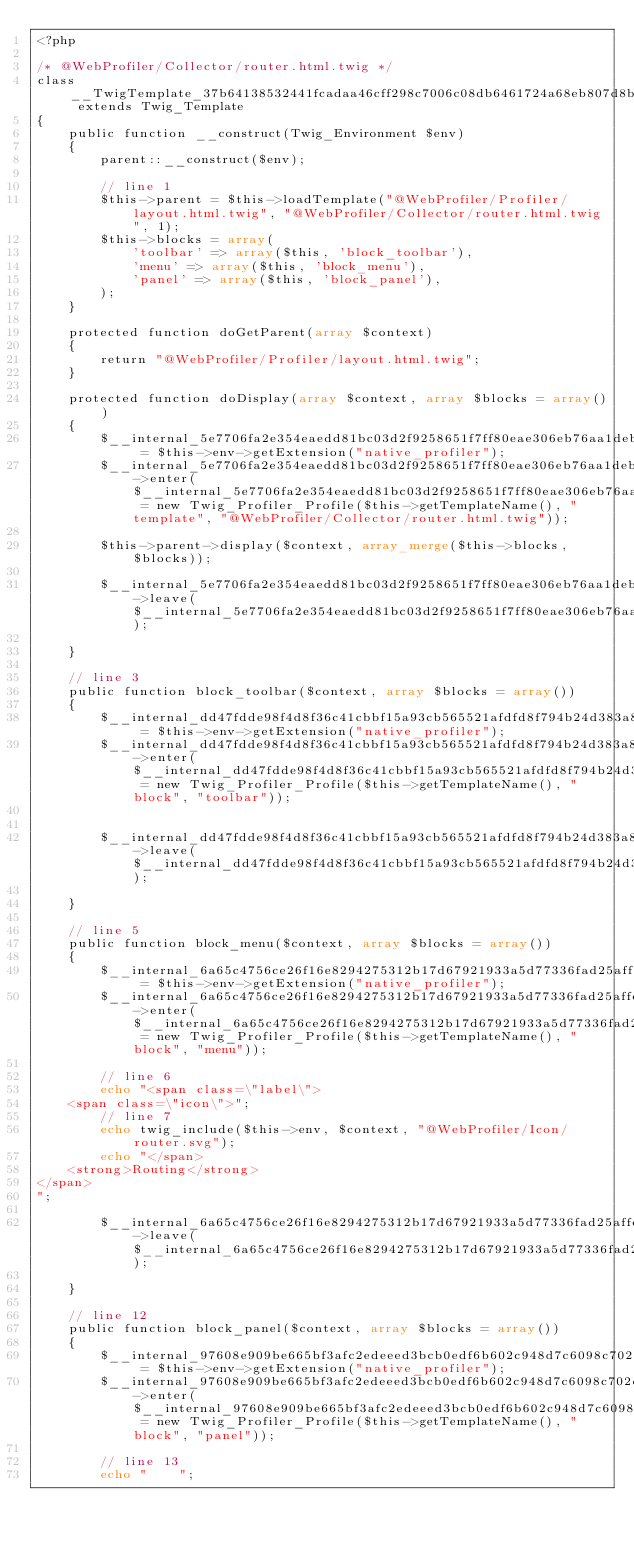<code> <loc_0><loc_0><loc_500><loc_500><_PHP_><?php

/* @WebProfiler/Collector/router.html.twig */
class __TwigTemplate_37b64138532441fcadaa46cff298c7006c08db6461724a68eb807d8b34bc1f9d extends Twig_Template
{
    public function __construct(Twig_Environment $env)
    {
        parent::__construct($env);

        // line 1
        $this->parent = $this->loadTemplate("@WebProfiler/Profiler/layout.html.twig", "@WebProfiler/Collector/router.html.twig", 1);
        $this->blocks = array(
            'toolbar' => array($this, 'block_toolbar'),
            'menu' => array($this, 'block_menu'),
            'panel' => array($this, 'block_panel'),
        );
    }

    protected function doGetParent(array $context)
    {
        return "@WebProfiler/Profiler/layout.html.twig";
    }

    protected function doDisplay(array $context, array $blocks = array())
    {
        $__internal_5e7706fa2e354eaedd81bc03d2f9258651f7ff80eae306eb76aa1deb5a367cd5 = $this->env->getExtension("native_profiler");
        $__internal_5e7706fa2e354eaedd81bc03d2f9258651f7ff80eae306eb76aa1deb5a367cd5->enter($__internal_5e7706fa2e354eaedd81bc03d2f9258651f7ff80eae306eb76aa1deb5a367cd5_prof = new Twig_Profiler_Profile($this->getTemplateName(), "template", "@WebProfiler/Collector/router.html.twig"));

        $this->parent->display($context, array_merge($this->blocks, $blocks));
        
        $__internal_5e7706fa2e354eaedd81bc03d2f9258651f7ff80eae306eb76aa1deb5a367cd5->leave($__internal_5e7706fa2e354eaedd81bc03d2f9258651f7ff80eae306eb76aa1deb5a367cd5_prof);

    }

    // line 3
    public function block_toolbar($context, array $blocks = array())
    {
        $__internal_dd47fdde98f4d8f36c41cbbf15a93cb565521afdfd8f794b24d383a88c045b30 = $this->env->getExtension("native_profiler");
        $__internal_dd47fdde98f4d8f36c41cbbf15a93cb565521afdfd8f794b24d383a88c045b30->enter($__internal_dd47fdde98f4d8f36c41cbbf15a93cb565521afdfd8f794b24d383a88c045b30_prof = new Twig_Profiler_Profile($this->getTemplateName(), "block", "toolbar"));

        
        $__internal_dd47fdde98f4d8f36c41cbbf15a93cb565521afdfd8f794b24d383a88c045b30->leave($__internal_dd47fdde98f4d8f36c41cbbf15a93cb565521afdfd8f794b24d383a88c045b30_prof);

    }

    // line 5
    public function block_menu($context, array $blocks = array())
    {
        $__internal_6a65c4756ce26f16e8294275312b17d67921933a5d77336fad25affecf274b52 = $this->env->getExtension("native_profiler");
        $__internal_6a65c4756ce26f16e8294275312b17d67921933a5d77336fad25affecf274b52->enter($__internal_6a65c4756ce26f16e8294275312b17d67921933a5d77336fad25affecf274b52_prof = new Twig_Profiler_Profile($this->getTemplateName(), "block", "menu"));

        // line 6
        echo "<span class=\"label\">
    <span class=\"icon\">";
        // line 7
        echo twig_include($this->env, $context, "@WebProfiler/Icon/router.svg");
        echo "</span>
    <strong>Routing</strong>
</span>
";
        
        $__internal_6a65c4756ce26f16e8294275312b17d67921933a5d77336fad25affecf274b52->leave($__internal_6a65c4756ce26f16e8294275312b17d67921933a5d77336fad25affecf274b52_prof);

    }

    // line 12
    public function block_panel($context, array $blocks = array())
    {
        $__internal_97608e909be665bf3afc2edeeed3bcb0edf6b602c948d7c6098c702d1fc5e809 = $this->env->getExtension("native_profiler");
        $__internal_97608e909be665bf3afc2edeeed3bcb0edf6b602c948d7c6098c702d1fc5e809->enter($__internal_97608e909be665bf3afc2edeeed3bcb0edf6b602c948d7c6098c702d1fc5e809_prof = new Twig_Profiler_Profile($this->getTemplateName(), "block", "panel"));

        // line 13
        echo "    ";</code> 